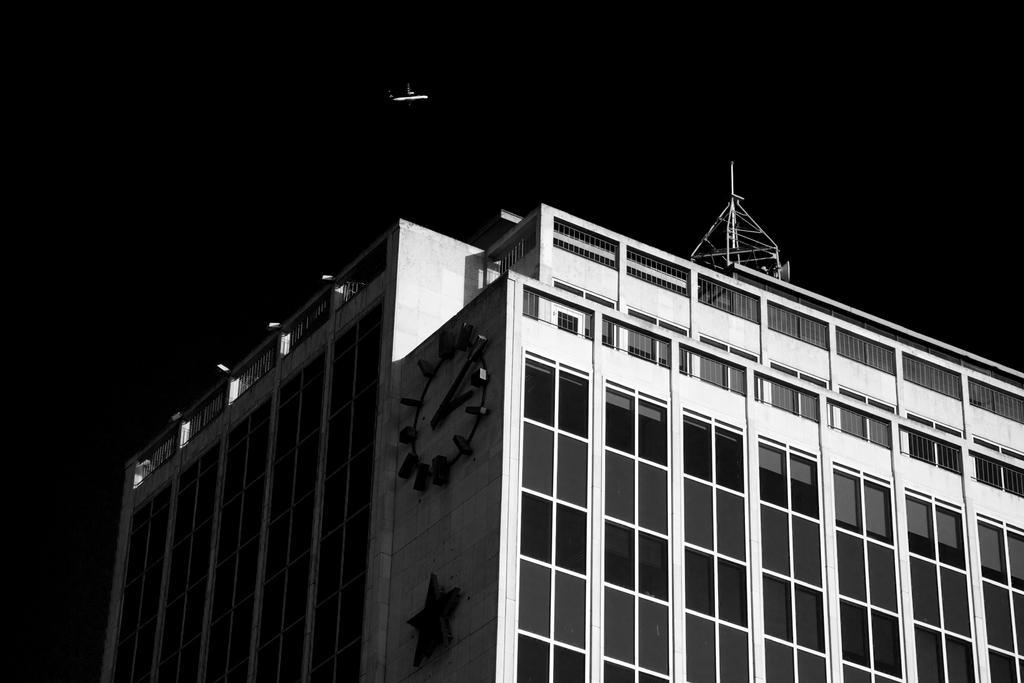Could you give a brief overview of what you see in this image? We can see building and tower and we can see clock on this building. We can see airplane in the air. In the background it is dark. 